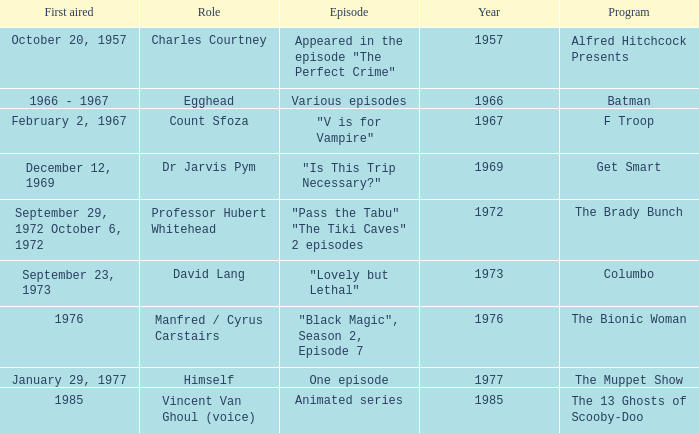Give me the full table as a dictionary. {'header': ['First aired', 'Role', 'Episode', 'Year', 'Program'], 'rows': [['October 20, 1957', 'Charles Courtney', 'Appeared in the episode "The Perfect Crime"', '1957', 'Alfred Hitchcock Presents'], ['1966 - 1967', 'Egghead', 'Various episodes', '1966', 'Batman'], ['February 2, 1967', 'Count Sfoza', '"V is for Vampire"', '1967', 'F Troop'], ['December 12, 1969', 'Dr Jarvis Pym', '"Is This Trip Necessary?"', '1969', 'Get Smart'], ['September 29, 1972 October 6, 1972', 'Professor Hubert Whitehead', '"Pass the Tabu" "The Tiki Caves" 2 episodes', '1972', 'The Brady Bunch'], ['September 23, 1973', 'David Lang', '"Lovely but Lethal"', '1973', 'Columbo'], ['1976', 'Manfred / Cyrus Carstairs', '"Black Magic", Season 2, Episode 7', '1976', 'The Bionic Woman'], ['January 29, 1977', 'Himself', 'One episode', '1977', 'The Muppet Show'], ['1985', 'Vincent Van Ghoul (voice)', 'Animated series', '1985', 'The 13 Ghosts of Scooby-Doo']]} What's the roles of the Bionic Woman? Manfred / Cyrus Carstairs. 